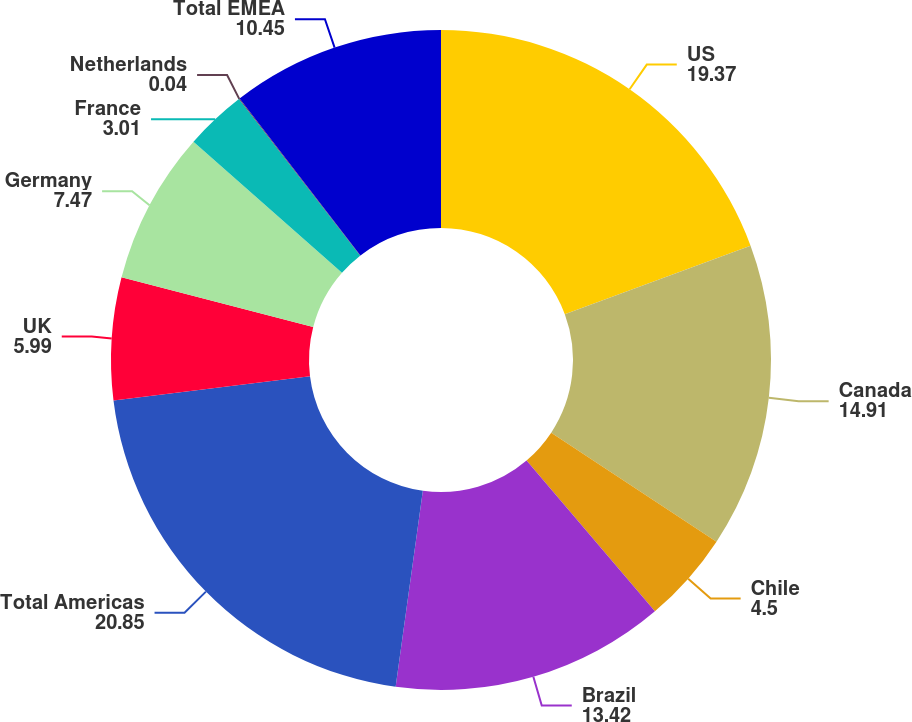Convert chart to OTSL. <chart><loc_0><loc_0><loc_500><loc_500><pie_chart><fcel>US<fcel>Canada<fcel>Chile<fcel>Brazil<fcel>Total Americas<fcel>UK<fcel>Germany<fcel>France<fcel>Netherlands<fcel>Total EMEA<nl><fcel>19.37%<fcel>14.91%<fcel>4.5%<fcel>13.42%<fcel>20.85%<fcel>5.99%<fcel>7.47%<fcel>3.01%<fcel>0.04%<fcel>10.45%<nl></chart> 